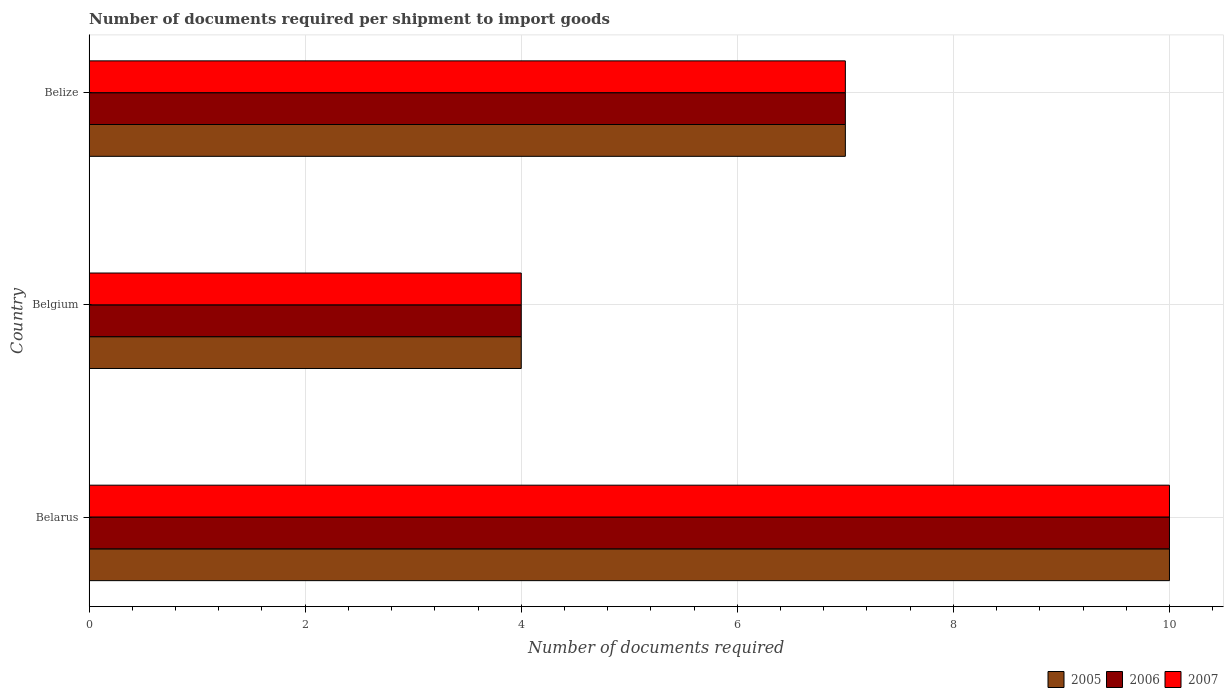How many different coloured bars are there?
Your answer should be compact. 3. How many groups of bars are there?
Give a very brief answer. 3. Are the number of bars per tick equal to the number of legend labels?
Keep it short and to the point. Yes. Are the number of bars on each tick of the Y-axis equal?
Provide a short and direct response. Yes. Across all countries, what is the minimum number of documents required per shipment to import goods in 2006?
Provide a succinct answer. 4. In which country was the number of documents required per shipment to import goods in 2007 maximum?
Your response must be concise. Belarus. In which country was the number of documents required per shipment to import goods in 2005 minimum?
Keep it short and to the point. Belgium. What is the total number of documents required per shipment to import goods in 2005 in the graph?
Make the answer very short. 21. What is the difference between the number of documents required per shipment to import goods in 2007 in Belarus and the number of documents required per shipment to import goods in 2005 in Belgium?
Ensure brevity in your answer.  6. In how many countries, is the number of documents required per shipment to import goods in 2006 greater than 8.4 ?
Your answer should be very brief. 1. What is the ratio of the number of documents required per shipment to import goods in 2006 in Belarus to that in Belize?
Ensure brevity in your answer.  1.43. Is the number of documents required per shipment to import goods in 2007 in Belarus less than that in Belize?
Provide a succinct answer. No. Is the difference between the number of documents required per shipment to import goods in 2007 in Belgium and Belize greater than the difference between the number of documents required per shipment to import goods in 2006 in Belgium and Belize?
Your answer should be compact. No. What is the difference between the highest and the second highest number of documents required per shipment to import goods in 2006?
Keep it short and to the point. 3. What is the difference between the highest and the lowest number of documents required per shipment to import goods in 2006?
Offer a very short reply. 6. Is the sum of the number of documents required per shipment to import goods in 2006 in Belarus and Belgium greater than the maximum number of documents required per shipment to import goods in 2007 across all countries?
Your answer should be compact. Yes. What does the 2nd bar from the top in Belgium represents?
Keep it short and to the point. 2006. What does the 3rd bar from the bottom in Belize represents?
Your answer should be very brief. 2007. Is it the case that in every country, the sum of the number of documents required per shipment to import goods in 2006 and number of documents required per shipment to import goods in 2007 is greater than the number of documents required per shipment to import goods in 2005?
Give a very brief answer. Yes. How many bars are there?
Give a very brief answer. 9. Are all the bars in the graph horizontal?
Provide a short and direct response. Yes. How many countries are there in the graph?
Offer a very short reply. 3. What is the difference between two consecutive major ticks on the X-axis?
Offer a terse response. 2. Are the values on the major ticks of X-axis written in scientific E-notation?
Keep it short and to the point. No. Does the graph contain any zero values?
Make the answer very short. No. Where does the legend appear in the graph?
Make the answer very short. Bottom right. How many legend labels are there?
Your answer should be compact. 3. What is the title of the graph?
Provide a succinct answer. Number of documents required per shipment to import goods. Does "1999" appear as one of the legend labels in the graph?
Make the answer very short. No. What is the label or title of the X-axis?
Give a very brief answer. Number of documents required. What is the Number of documents required in 2005 in Belarus?
Provide a short and direct response. 10. What is the Number of documents required of 2006 in Belarus?
Make the answer very short. 10. What is the Number of documents required of 2007 in Belarus?
Ensure brevity in your answer.  10. What is the Number of documents required of 2005 in Belgium?
Give a very brief answer. 4. What is the Number of documents required of 2006 in Belgium?
Offer a terse response. 4. What is the Number of documents required of 2006 in Belize?
Provide a short and direct response. 7. Across all countries, what is the maximum Number of documents required in 2005?
Provide a succinct answer. 10. Across all countries, what is the minimum Number of documents required in 2007?
Offer a very short reply. 4. What is the difference between the Number of documents required of 2005 in Belarus and that in Belize?
Offer a very short reply. 3. What is the difference between the Number of documents required of 2007 in Belarus and that in Belize?
Provide a short and direct response. 3. What is the difference between the Number of documents required in 2005 in Belgium and that in Belize?
Keep it short and to the point. -3. What is the difference between the Number of documents required in 2007 in Belgium and that in Belize?
Your response must be concise. -3. What is the difference between the Number of documents required of 2006 in Belarus and the Number of documents required of 2007 in Belgium?
Your answer should be compact. 6. What is the difference between the Number of documents required of 2005 in Belgium and the Number of documents required of 2007 in Belize?
Offer a very short reply. -3. What is the average Number of documents required in 2005 per country?
Make the answer very short. 7. What is the average Number of documents required of 2006 per country?
Provide a short and direct response. 7. What is the difference between the Number of documents required in 2005 and Number of documents required in 2007 in Belarus?
Provide a short and direct response. 0. What is the difference between the Number of documents required in 2006 and Number of documents required in 2007 in Belgium?
Keep it short and to the point. 0. What is the ratio of the Number of documents required of 2006 in Belarus to that in Belgium?
Give a very brief answer. 2.5. What is the ratio of the Number of documents required in 2007 in Belarus to that in Belgium?
Give a very brief answer. 2.5. What is the ratio of the Number of documents required in 2005 in Belarus to that in Belize?
Provide a short and direct response. 1.43. What is the ratio of the Number of documents required of 2006 in Belarus to that in Belize?
Your answer should be very brief. 1.43. What is the ratio of the Number of documents required of 2007 in Belarus to that in Belize?
Your answer should be very brief. 1.43. What is the ratio of the Number of documents required of 2007 in Belgium to that in Belize?
Provide a short and direct response. 0.57. What is the difference between the highest and the second highest Number of documents required of 2005?
Your response must be concise. 3. What is the difference between the highest and the second highest Number of documents required in 2006?
Ensure brevity in your answer.  3. What is the difference between the highest and the lowest Number of documents required of 2005?
Offer a very short reply. 6. What is the difference between the highest and the lowest Number of documents required of 2007?
Ensure brevity in your answer.  6. 